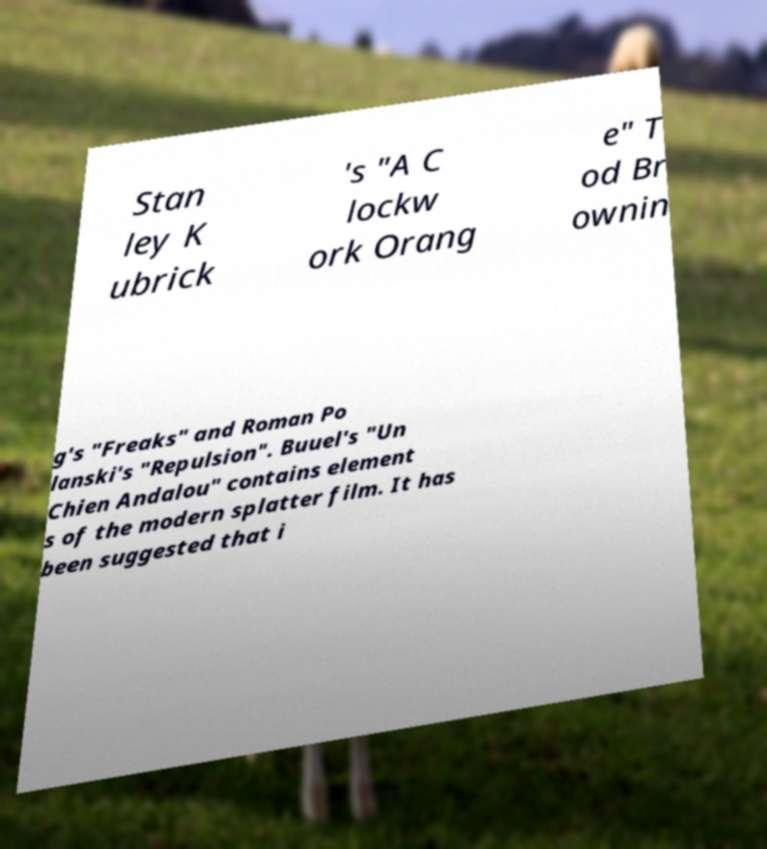I need the written content from this picture converted into text. Can you do that? Stan ley K ubrick 's "A C lockw ork Orang e" T od Br ownin g's "Freaks" and Roman Po lanski's "Repulsion". Buuel's "Un Chien Andalou" contains element s of the modern splatter film. It has been suggested that i 